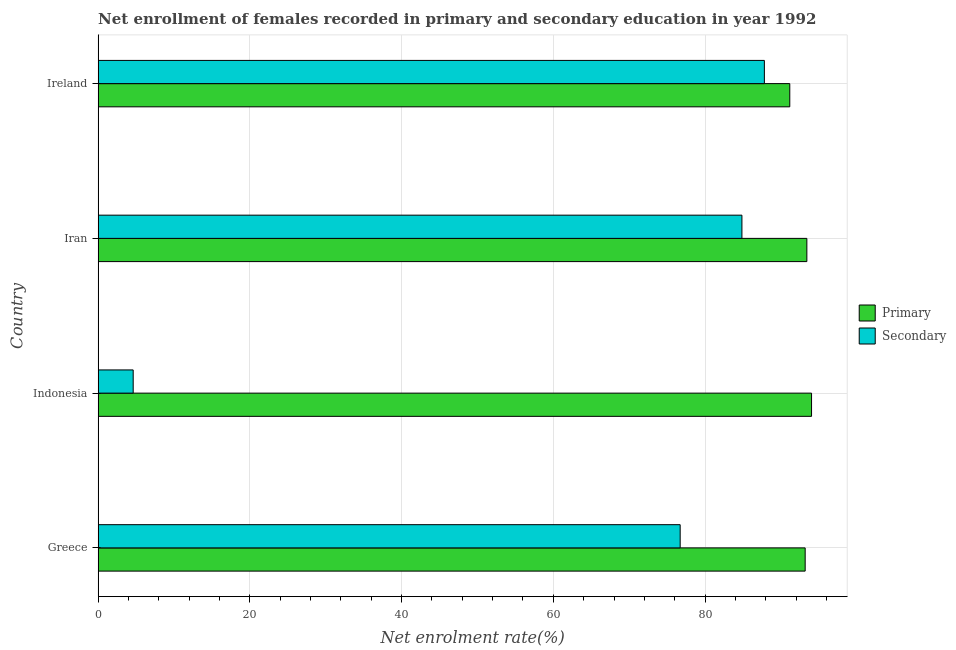What is the label of the 4th group of bars from the top?
Your answer should be compact. Greece. In how many cases, is the number of bars for a given country not equal to the number of legend labels?
Your answer should be very brief. 0. What is the enrollment rate in secondary education in Greece?
Provide a succinct answer. 76.72. Across all countries, what is the maximum enrollment rate in secondary education?
Your answer should be compact. 87.82. Across all countries, what is the minimum enrollment rate in secondary education?
Ensure brevity in your answer.  4.62. In which country was the enrollment rate in secondary education minimum?
Keep it short and to the point. Indonesia. What is the total enrollment rate in secondary education in the graph?
Make the answer very short. 254.01. What is the difference between the enrollment rate in secondary education in Greece and that in Iran?
Keep it short and to the point. -8.14. What is the difference between the enrollment rate in secondary education in Iran and the enrollment rate in primary education in Greece?
Make the answer very short. -8.34. What is the average enrollment rate in secondary education per country?
Keep it short and to the point. 63.5. What is the difference between the enrollment rate in primary education and enrollment rate in secondary education in Ireland?
Offer a terse response. 3.35. What is the ratio of the enrollment rate in secondary education in Indonesia to that in Iran?
Ensure brevity in your answer.  0.05. What is the difference between the highest and the second highest enrollment rate in primary education?
Ensure brevity in your answer.  0.62. What is the difference between the highest and the lowest enrollment rate in secondary education?
Your answer should be very brief. 83.19. What does the 1st bar from the top in Greece represents?
Make the answer very short. Secondary. What does the 2nd bar from the bottom in Ireland represents?
Give a very brief answer. Secondary. Are all the bars in the graph horizontal?
Keep it short and to the point. Yes. How many countries are there in the graph?
Keep it short and to the point. 4. Does the graph contain any zero values?
Make the answer very short. No. Does the graph contain grids?
Make the answer very short. Yes. Where does the legend appear in the graph?
Offer a terse response. Center right. How are the legend labels stacked?
Keep it short and to the point. Vertical. What is the title of the graph?
Provide a succinct answer. Net enrollment of females recorded in primary and secondary education in year 1992. Does "Resident workers" appear as one of the legend labels in the graph?
Ensure brevity in your answer.  No. What is the label or title of the X-axis?
Your answer should be very brief. Net enrolment rate(%). What is the Net enrolment rate(%) in Primary in Greece?
Your response must be concise. 93.19. What is the Net enrolment rate(%) in Secondary in Greece?
Your response must be concise. 76.72. What is the Net enrolment rate(%) in Primary in Indonesia?
Provide a succinct answer. 94.03. What is the Net enrolment rate(%) in Secondary in Indonesia?
Offer a terse response. 4.62. What is the Net enrolment rate(%) of Primary in Iran?
Ensure brevity in your answer.  93.41. What is the Net enrolment rate(%) in Secondary in Iran?
Keep it short and to the point. 84.86. What is the Net enrolment rate(%) in Primary in Ireland?
Ensure brevity in your answer.  91.16. What is the Net enrolment rate(%) in Secondary in Ireland?
Your answer should be compact. 87.82. Across all countries, what is the maximum Net enrolment rate(%) in Primary?
Provide a short and direct response. 94.03. Across all countries, what is the maximum Net enrolment rate(%) of Secondary?
Make the answer very short. 87.82. Across all countries, what is the minimum Net enrolment rate(%) of Primary?
Offer a terse response. 91.16. Across all countries, what is the minimum Net enrolment rate(%) of Secondary?
Your answer should be compact. 4.62. What is the total Net enrolment rate(%) of Primary in the graph?
Provide a short and direct response. 371.8. What is the total Net enrolment rate(%) in Secondary in the graph?
Offer a terse response. 254.01. What is the difference between the Net enrolment rate(%) in Primary in Greece and that in Indonesia?
Keep it short and to the point. -0.84. What is the difference between the Net enrolment rate(%) in Secondary in Greece and that in Indonesia?
Your answer should be compact. 72.09. What is the difference between the Net enrolment rate(%) in Primary in Greece and that in Iran?
Give a very brief answer. -0.22. What is the difference between the Net enrolment rate(%) in Secondary in Greece and that in Iran?
Your response must be concise. -8.14. What is the difference between the Net enrolment rate(%) in Primary in Greece and that in Ireland?
Offer a terse response. 2.03. What is the difference between the Net enrolment rate(%) of Secondary in Greece and that in Ireland?
Keep it short and to the point. -11.1. What is the difference between the Net enrolment rate(%) in Primary in Indonesia and that in Iran?
Make the answer very short. 0.62. What is the difference between the Net enrolment rate(%) in Secondary in Indonesia and that in Iran?
Your answer should be compact. -80.23. What is the difference between the Net enrolment rate(%) of Primary in Indonesia and that in Ireland?
Your answer should be compact. 2.87. What is the difference between the Net enrolment rate(%) in Secondary in Indonesia and that in Ireland?
Ensure brevity in your answer.  -83.19. What is the difference between the Net enrolment rate(%) of Primary in Iran and that in Ireland?
Keep it short and to the point. 2.25. What is the difference between the Net enrolment rate(%) in Secondary in Iran and that in Ireland?
Keep it short and to the point. -2.96. What is the difference between the Net enrolment rate(%) of Primary in Greece and the Net enrolment rate(%) of Secondary in Indonesia?
Your answer should be very brief. 88.57. What is the difference between the Net enrolment rate(%) in Primary in Greece and the Net enrolment rate(%) in Secondary in Iran?
Your response must be concise. 8.34. What is the difference between the Net enrolment rate(%) in Primary in Greece and the Net enrolment rate(%) in Secondary in Ireland?
Your answer should be compact. 5.38. What is the difference between the Net enrolment rate(%) in Primary in Indonesia and the Net enrolment rate(%) in Secondary in Iran?
Keep it short and to the point. 9.18. What is the difference between the Net enrolment rate(%) of Primary in Indonesia and the Net enrolment rate(%) of Secondary in Ireland?
Offer a very short reply. 6.22. What is the difference between the Net enrolment rate(%) of Primary in Iran and the Net enrolment rate(%) of Secondary in Ireland?
Ensure brevity in your answer.  5.6. What is the average Net enrolment rate(%) in Primary per country?
Give a very brief answer. 92.95. What is the average Net enrolment rate(%) in Secondary per country?
Ensure brevity in your answer.  63.5. What is the difference between the Net enrolment rate(%) in Primary and Net enrolment rate(%) in Secondary in Greece?
Offer a very short reply. 16.48. What is the difference between the Net enrolment rate(%) in Primary and Net enrolment rate(%) in Secondary in Indonesia?
Your response must be concise. 89.41. What is the difference between the Net enrolment rate(%) of Primary and Net enrolment rate(%) of Secondary in Iran?
Keep it short and to the point. 8.56. What is the difference between the Net enrolment rate(%) in Primary and Net enrolment rate(%) in Secondary in Ireland?
Ensure brevity in your answer.  3.35. What is the ratio of the Net enrolment rate(%) of Secondary in Greece to that in Indonesia?
Offer a terse response. 16.6. What is the ratio of the Net enrolment rate(%) of Primary in Greece to that in Iran?
Your answer should be very brief. 1. What is the ratio of the Net enrolment rate(%) in Secondary in Greece to that in Iran?
Give a very brief answer. 0.9. What is the ratio of the Net enrolment rate(%) of Primary in Greece to that in Ireland?
Give a very brief answer. 1.02. What is the ratio of the Net enrolment rate(%) of Secondary in Greece to that in Ireland?
Your answer should be very brief. 0.87. What is the ratio of the Net enrolment rate(%) of Primary in Indonesia to that in Iran?
Give a very brief answer. 1.01. What is the ratio of the Net enrolment rate(%) of Secondary in Indonesia to that in Iran?
Make the answer very short. 0.05. What is the ratio of the Net enrolment rate(%) in Primary in Indonesia to that in Ireland?
Your answer should be compact. 1.03. What is the ratio of the Net enrolment rate(%) in Secondary in Indonesia to that in Ireland?
Keep it short and to the point. 0.05. What is the ratio of the Net enrolment rate(%) of Primary in Iran to that in Ireland?
Offer a very short reply. 1.02. What is the ratio of the Net enrolment rate(%) in Secondary in Iran to that in Ireland?
Give a very brief answer. 0.97. What is the difference between the highest and the second highest Net enrolment rate(%) in Primary?
Make the answer very short. 0.62. What is the difference between the highest and the second highest Net enrolment rate(%) of Secondary?
Provide a short and direct response. 2.96. What is the difference between the highest and the lowest Net enrolment rate(%) in Primary?
Your answer should be very brief. 2.87. What is the difference between the highest and the lowest Net enrolment rate(%) in Secondary?
Your answer should be very brief. 83.19. 